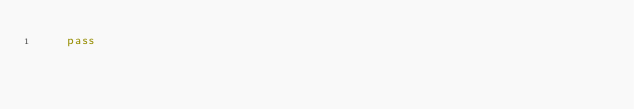Convert code to text. <code><loc_0><loc_0><loc_500><loc_500><_Python_>    pass
</code> 